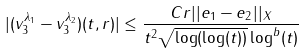Convert formula to latex. <formula><loc_0><loc_0><loc_500><loc_500>| ( v _ { 3 } ^ { \lambda _ { 1 } } - v _ { 3 } ^ { \lambda _ { 2 } } ) ( t , r ) | & \leq \frac { C r | | e _ { 1 } - e _ { 2 } | | _ { X } } { t ^ { 2 } \sqrt { \log ( \log ( t ) ) } \log ^ { b } ( t ) }</formula> 